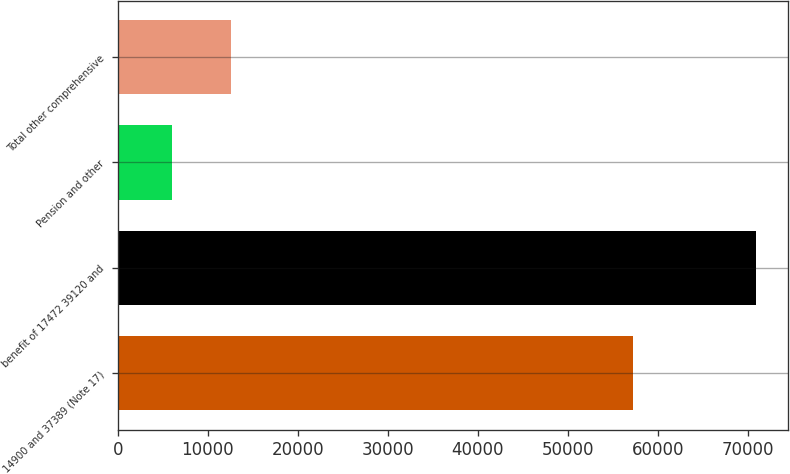Convert chart to OTSL. <chart><loc_0><loc_0><loc_500><loc_500><bar_chart><fcel>14900 and 37389 (Note 17)<fcel>benefit of 17472 39120 and<fcel>Pension and other<fcel>Total other comprehensive<nl><fcel>57271<fcel>70902<fcel>6026<fcel>12513.6<nl></chart> 